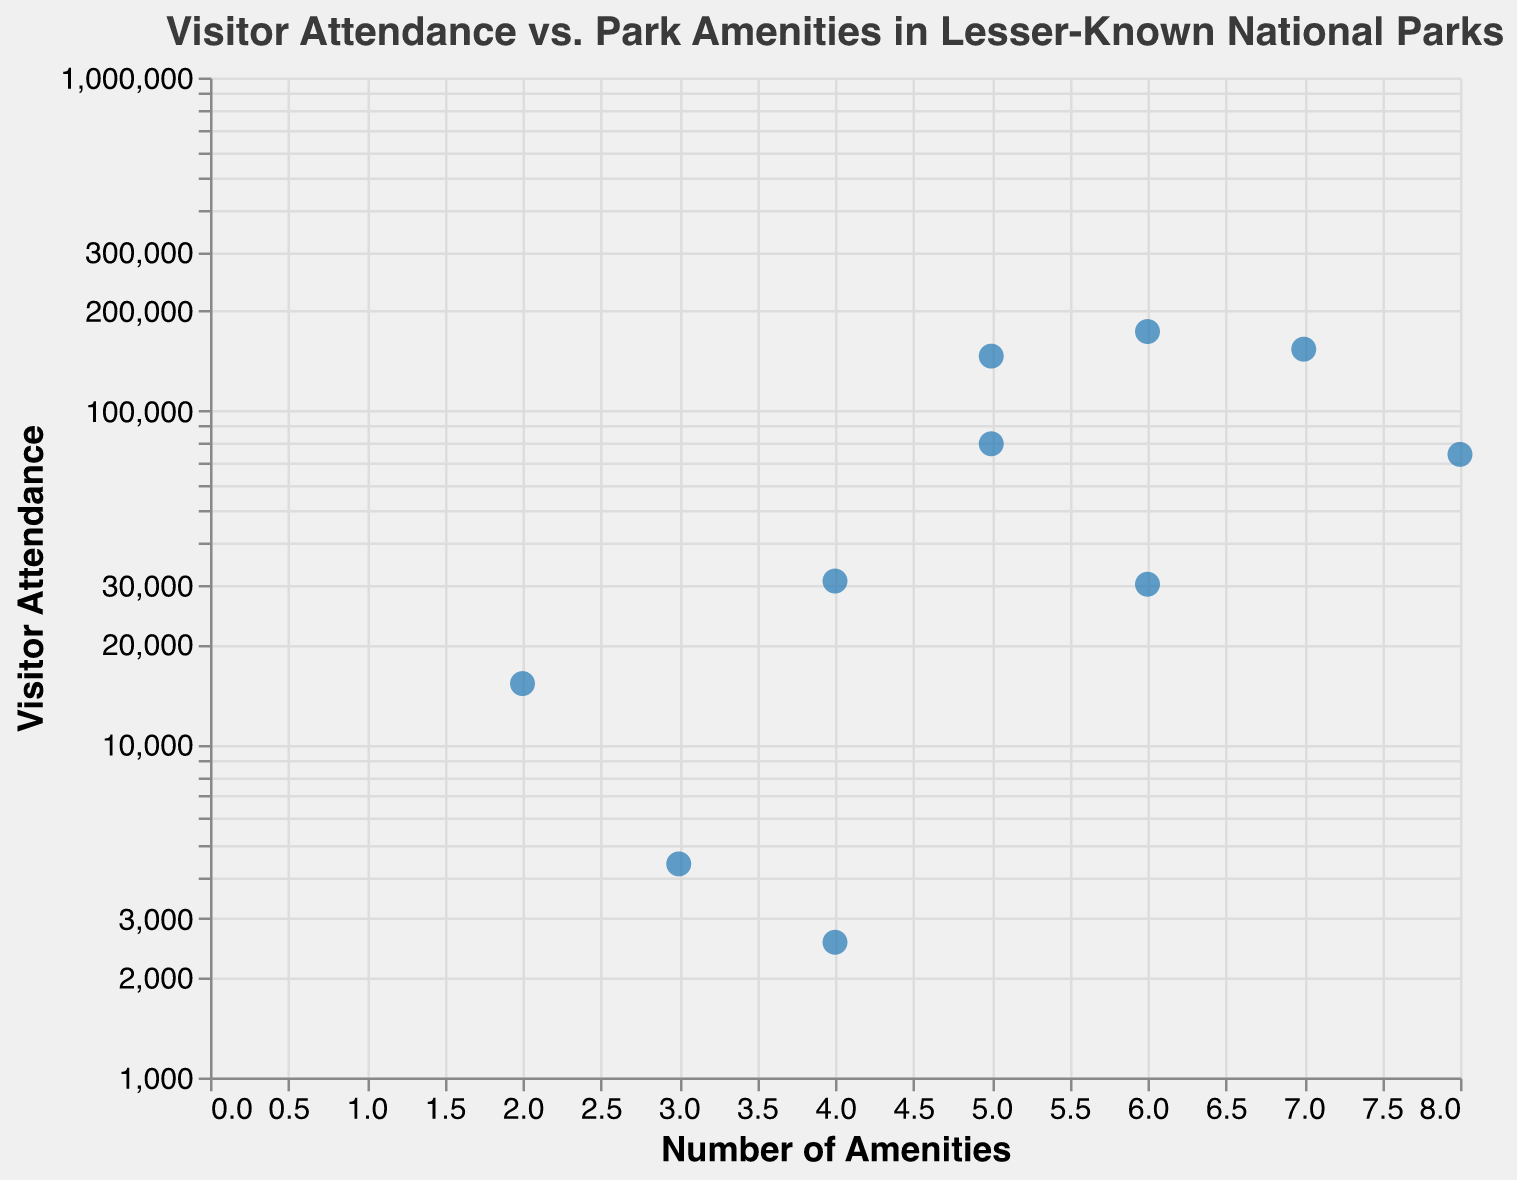What is the title of the scatter plot? The title of the scatter plot is displayed at the top of the chart. It reads "Visitor Attendance vs. Park Amenities in Lesser-Known National Parks."
Answer: Visitor Attendance vs. Park Amenities in Lesser-Known National Parks How many parks are represented in the scatter plot? Each unique data point in the scatter plot represents a different park. By counting the markers, we see there are 10 data points.
Answer: 10 Which park has the lowest visitor attendance? By examining the y-axis values, the point at the bottom of the scatter plot corresponds to the park with the lowest visitor attendance, which is "Isle Royale National Park" with 2,545 visitors.
Answer: Isle Royale National Park Which park offers the most amenities? The highest value on the x-axis corresponds to the park with the most amenities. The scatter plot shows the point farthest to the right, which is "Wrangell-St. Elias National Park" with 8 amenities.
Answer: Wrangell-St. Elias National Park How many parks have more than 5 amenities? Count the number of points with x-axis values greater than 5. The parks are "Great Basin National Park" (7), "North Cascades National Park" (6), "Wrangell-St. Elias National Park" (8), and "Guadalupe Mountains National Park" (6). There are 4 parks.
Answer: 4 What is the average visitor attendance for parks with exactly 5 amenities? Identify the points with x-axis value of 5: "Congaree National Park" (145,929 visitors) and "Dry Tortugas National Park" (79,650 visitors). Calculate the average: (145,929 + 79,650) / 2 = 112,789.5 visitors.
Answer: 112,789.5 Which park has the highest visitor attendance, and how many amenities does it have? The point at the top of the scatter plot corresponds to the highest visitor attendance, belonging to "Guadalupe Mountains National Park" with 172,922 visitors and 6 amenities.
Answer: Guadalupe Mountains National Park, 6 Comparatively, does "Kobuk Valley National Park" have higher or lower visitor attendance than "Lake Clark National Park"? Locate the points representing both parks: "Kobuk Valley National Park" has 15,197 visitors while "Lake Clark National Park" has 4,373 visitors. Kobuk Valley has higher attendance.
Answer: Higher Describe the general trend between visitor attendance and park amenities based on the scatter plot. Upon examining the scatter plot, it appears that there is a somewhat increasing trend—the parks with more amenities generally tend to have higher visitor attendance, though there are exceptions.
Answer: Increasing trend Which park has the second lowest visitor attendance and how many amenities does it offer? The second lowest point on the y-axis represents this park: "Lake Clark National Park" with 4,373 visitors and it offers 3 amenities.
Answer: Lake Clark National Park, 3 